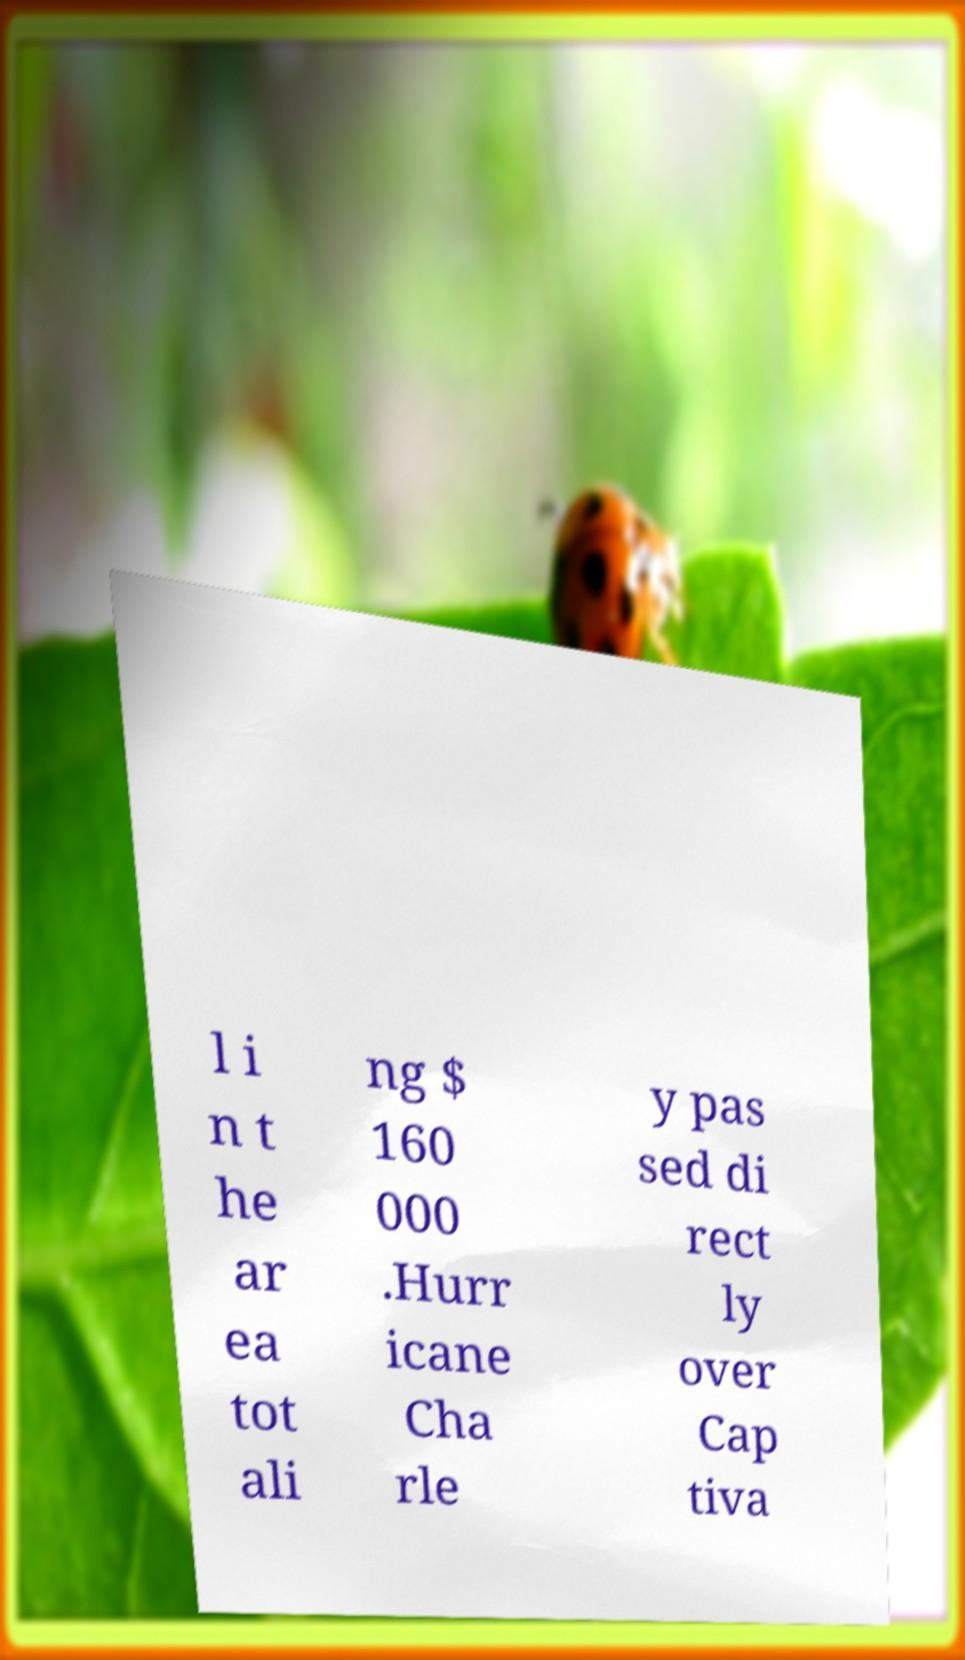Please read and relay the text visible in this image. What does it say? l i n t he ar ea tot ali ng $ 160 000 .Hurr icane Cha rle y pas sed di rect ly over Cap tiva 